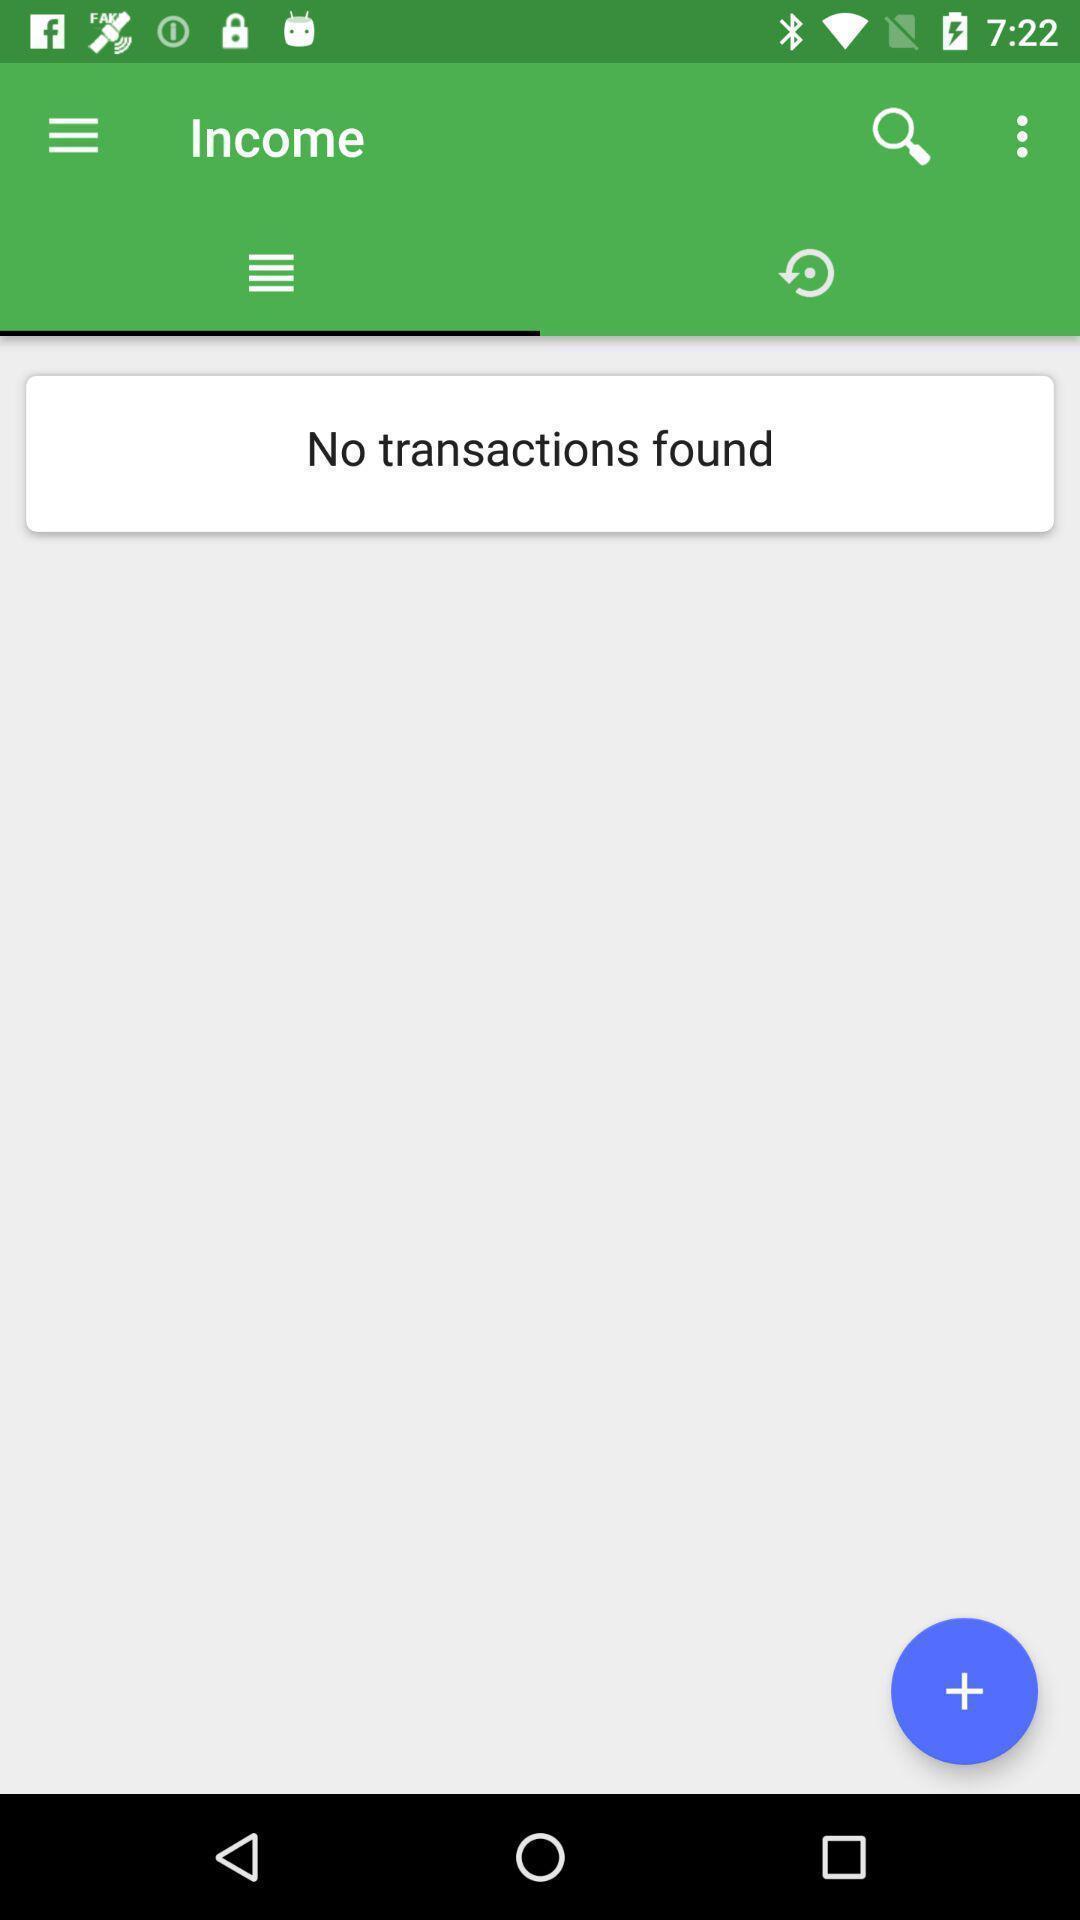What details can you identify in this image? Screen showing transactions page of a payment app. 